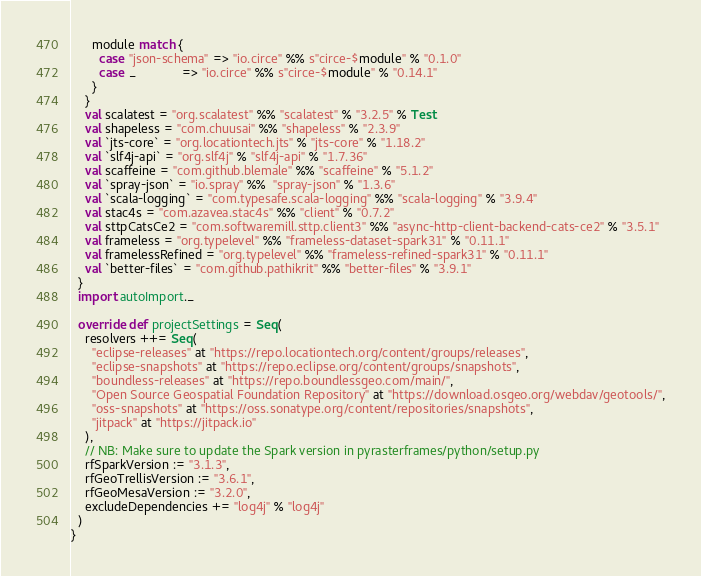<code> <loc_0><loc_0><loc_500><loc_500><_Scala_>      module match {
        case "json-schema" => "io.circe" %% s"circe-$module" % "0.1.0"
        case _             => "io.circe" %% s"circe-$module" % "0.14.1"
      }
    }
    val scalatest = "org.scalatest" %% "scalatest" % "3.2.5" % Test
    val shapeless = "com.chuusai" %% "shapeless" % "2.3.9"
    val `jts-core` = "org.locationtech.jts" % "jts-core" % "1.18.2"
    val `slf4j-api` = "org.slf4j" % "slf4j-api" % "1.7.36"
    val scaffeine = "com.github.blemale" %% "scaffeine" % "5.1.2"
    val `spray-json` = "io.spray" %%  "spray-json" % "1.3.6"
    val `scala-logging` = "com.typesafe.scala-logging" %% "scala-logging" % "3.9.4"
    val stac4s = "com.azavea.stac4s" %% "client" % "0.7.2"
    val sttpCatsCe2 = "com.softwaremill.sttp.client3" %% "async-http-client-backend-cats-ce2" % "3.5.1"
    val frameless = "org.typelevel" %% "frameless-dataset-spark31" % "0.11.1"
    val framelessRefined = "org.typelevel" %% "frameless-refined-spark31" % "0.11.1"
    val `better-files` = "com.github.pathikrit" %% "better-files" % "3.9.1" 
  }
  import autoImport._

  override def projectSettings = Seq(
    resolvers ++= Seq(
      "eclipse-releases" at "https://repo.locationtech.org/content/groups/releases",
      "eclipse-snapshots" at "https://repo.eclipse.org/content/groups/snapshots",
      "boundless-releases" at "https://repo.boundlessgeo.com/main/",
      "Open Source Geospatial Foundation Repository" at "https://download.osgeo.org/webdav/geotools/",
      "oss-snapshots" at "https://oss.sonatype.org/content/repositories/snapshots",
      "jitpack" at "https://jitpack.io"
    ),
    // NB: Make sure to update the Spark version in pyrasterframes/python/setup.py
    rfSparkVersion := "3.1.3",
    rfGeoTrellisVersion := "3.6.1",
    rfGeoMesaVersion := "3.2.0",
    excludeDependencies += "log4j" % "log4j"
  )
}
</code> 